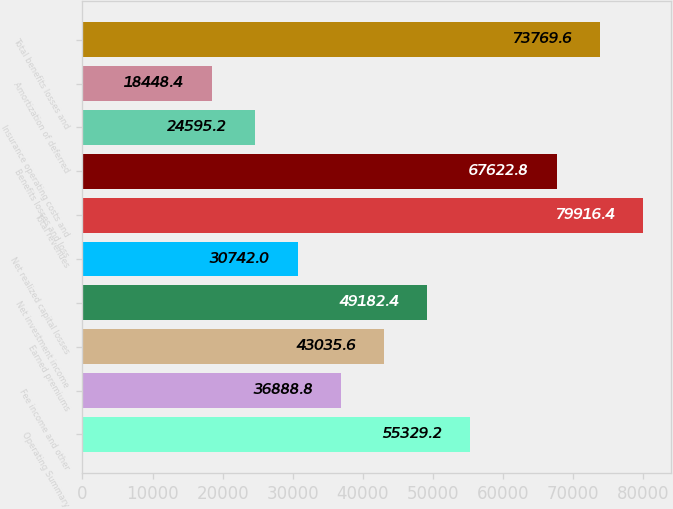Convert chart to OTSL. <chart><loc_0><loc_0><loc_500><loc_500><bar_chart><fcel>Operating Summary<fcel>Fee income and other<fcel>Earned premiums<fcel>Net investment income<fcel>Net realized capital losses<fcel>Total revenues<fcel>Benefits losses and loss<fcel>Insurance operating costs and<fcel>Amortization of deferred<fcel>Total benefits losses and<nl><fcel>55329.2<fcel>36888.8<fcel>43035.6<fcel>49182.4<fcel>30742<fcel>79916.4<fcel>67622.8<fcel>24595.2<fcel>18448.4<fcel>73769.6<nl></chart> 